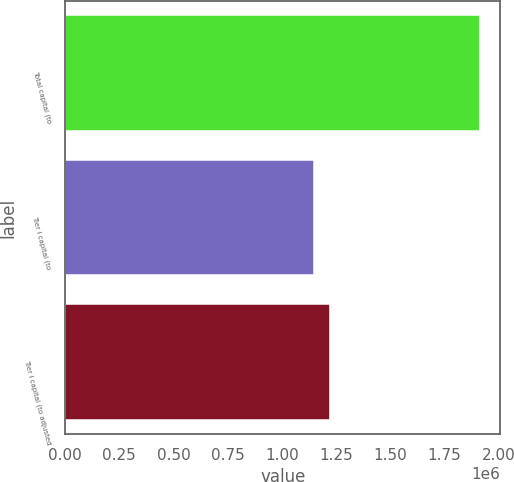Convert chart to OTSL. <chart><loc_0><loc_0><loc_500><loc_500><bar_chart><fcel>Total capital (to<fcel>Tier I capital (to<fcel>Tier I capital (to adjusted<nl><fcel>1.91397e+06<fcel>1.14838e+06<fcel>1.22494e+06<nl></chart> 